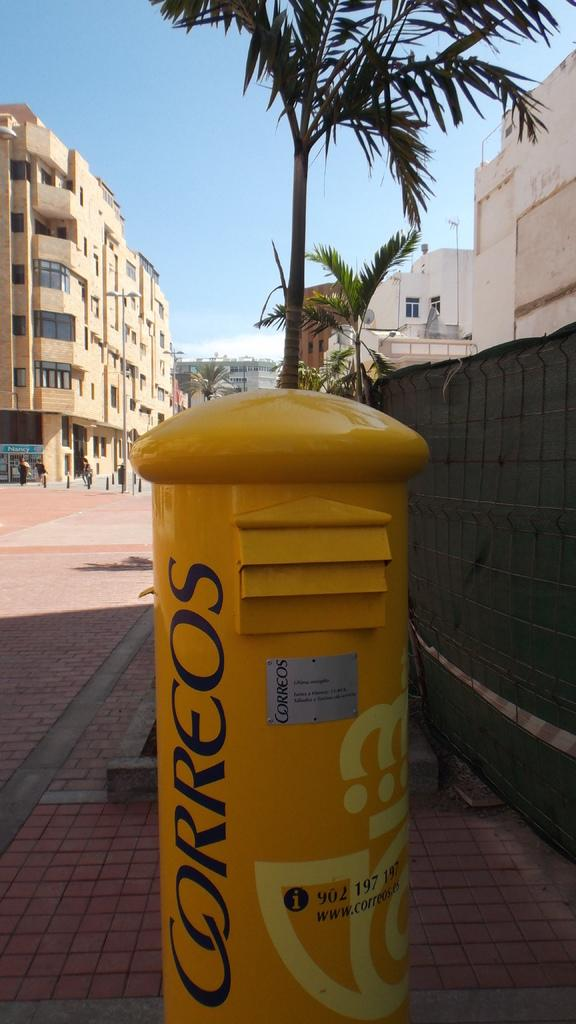Provide a one-sentence caption for the provided image. A tall yellow container with the word Correos on it. 